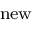<formula> <loc_0><loc_0><loc_500><loc_500>_ { n e w }</formula> 